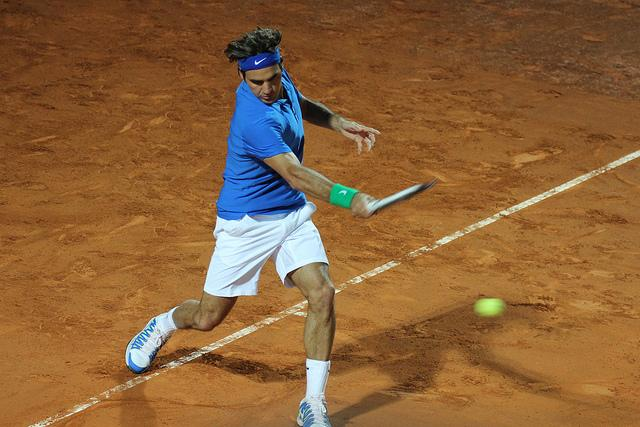What is the man wearing? Please explain your reasoning. bandana. The man has a blue headband around his top part of his head. this helps keep the hair out of his face as well as sweat. 